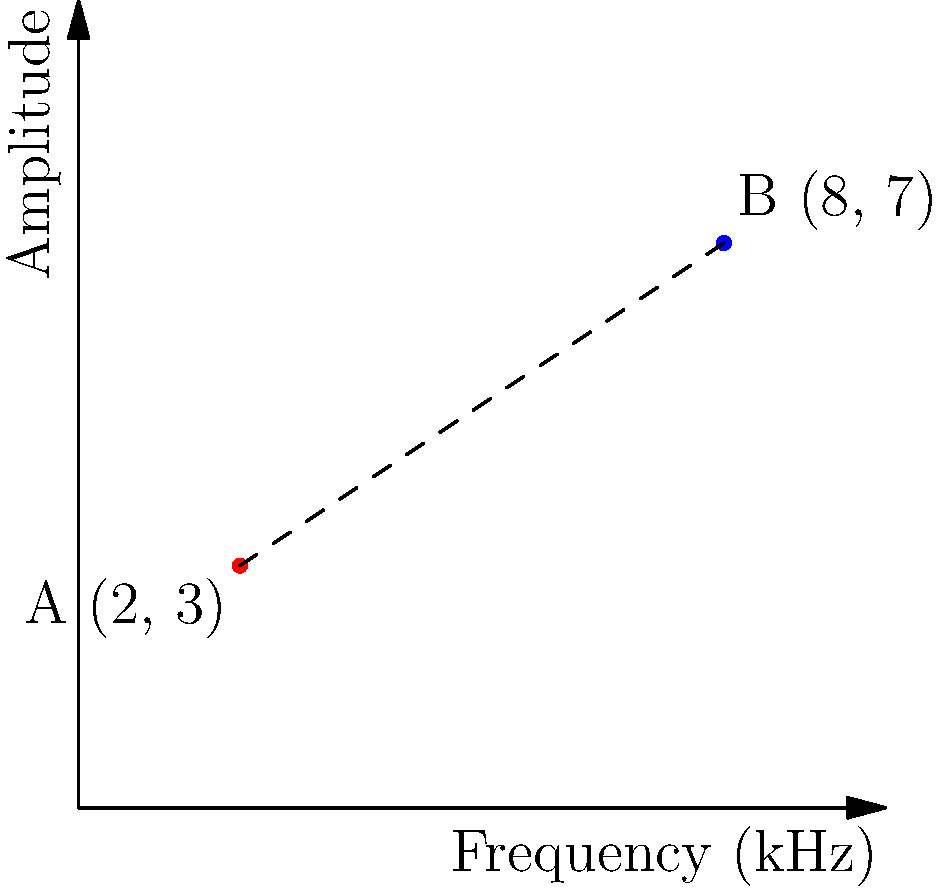On a synthesizer's oscillator graph, two points represent different frequency and amplitude settings. Point A has coordinates (2, 3) and Point B has coordinates (8, 7), where the x-axis represents frequency in kHz and the y-axis represents amplitude. Calculate the distance between these two points to determine the range of the oscillator's modulation. To calculate the distance between two points in a 2D plane, we use the distance formula, which is derived from the Pythagorean theorem:

$$d = \sqrt{(x_2 - x_1)^2 + (y_2 - y_1)^2}$$

Where $(x_1, y_1)$ are the coordinates of the first point and $(x_2, y_2)$ are the coordinates of the second point.

Given:
Point A: $(x_1, y_1) = (2, 3)$
Point B: $(x_2, y_2) = (8, 7)$

Let's substitute these values into the formula:

$$d = \sqrt{(8 - 2)^2 + (7 - 3)^2}$$

Now, let's solve step by step:

1. Calculate the differences:
   $$d = \sqrt{(6)^2 + (4)^2}$$

2. Square the differences:
   $$d = \sqrt{36 + 16}$$

3. Add the squared differences:
   $$d = \sqrt{52}$$

4. Calculate the square root:
   $$d = \sqrt{52} \approx 7.21$$

Therefore, the distance between the two points, representing the range of the oscillator's modulation, is approximately 7.21 units on the graph.
Answer: $7.21$ units 